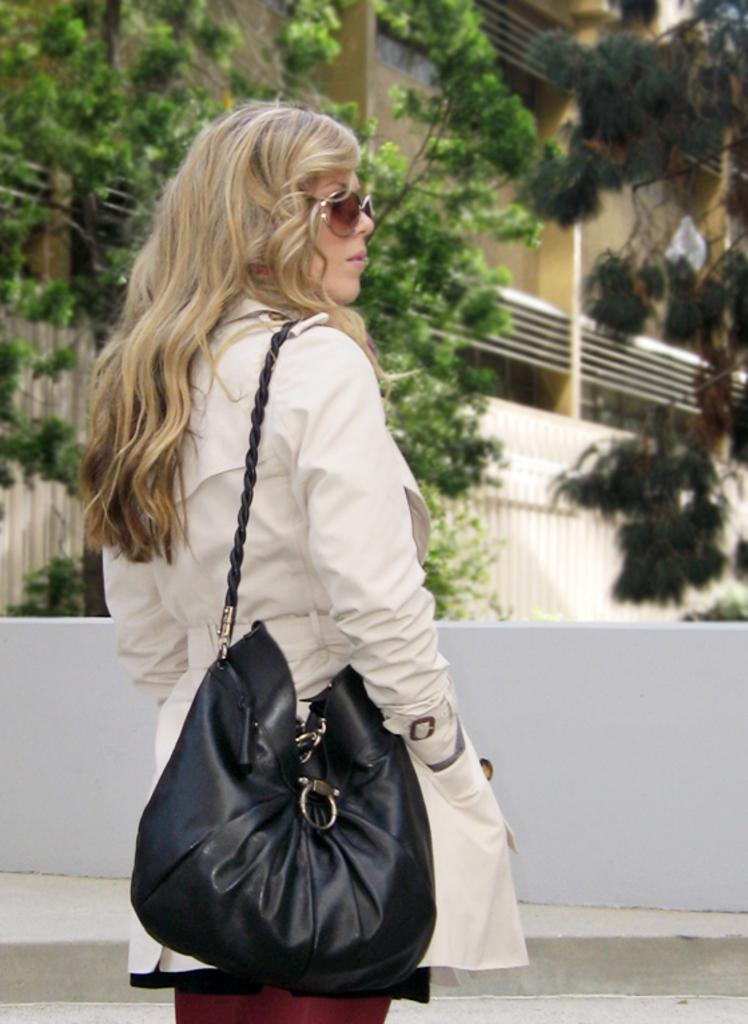Who is present in the image? There are women in the image. What are the women wearing on their faces? The women are wearing goggles. What are the women holding in their hands? The women are carrying bags. What is the surface the women are standing on? The women are standing on a floor. What can be seen in the background of the image? There is a wall, trees, a building, and wires in the background of the image. What type of fear can be seen on the women's faces in the image? There is no indication of fear on the women's faces in the image. Can you see any ducks in the image? There are no ducks present in the image. 